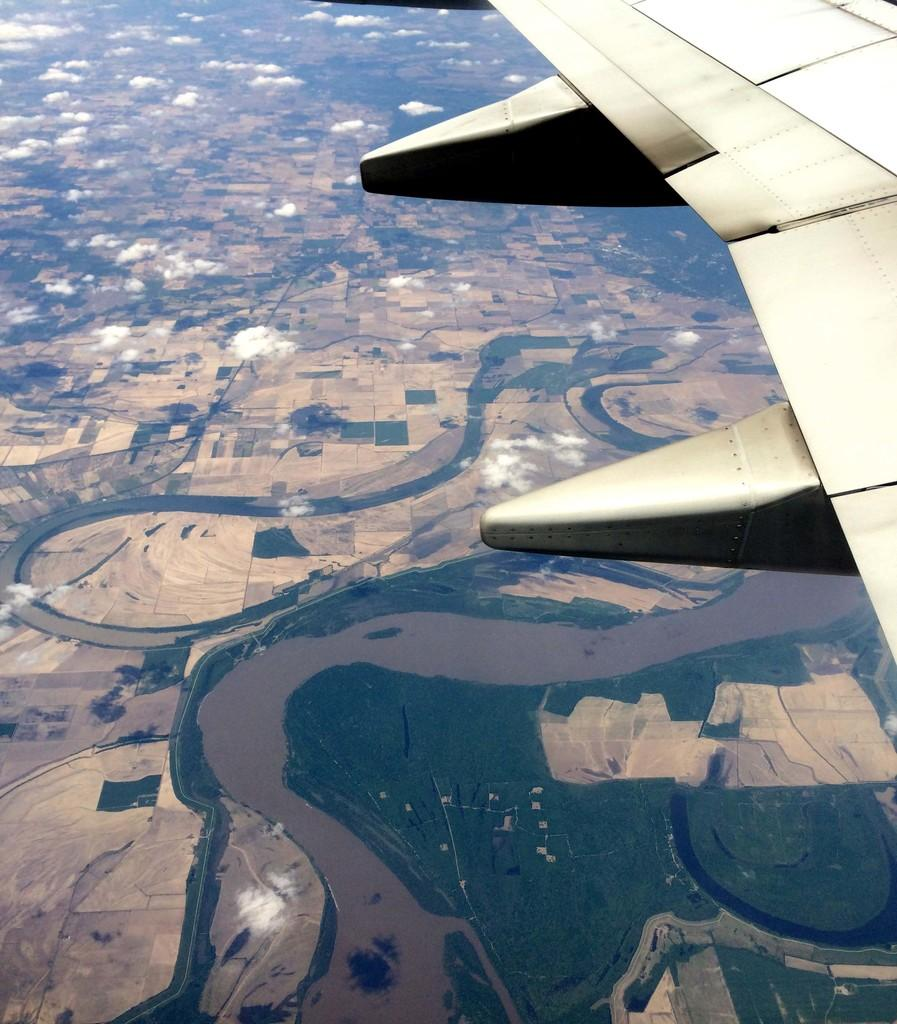What type of surface is visible in the image? There is ground visible in the image. What is located on the right side of the image? There is an aeroplane wing on the right side of the image. How is the aeroplane wing depicted in the image? The aeroplane wing appears to be truncated. What type of invention is being sold for a dime in the image? There is no invention or reference to a dime present in the image. What emotion is being expressed by the aeroplane wing in the image? The aeroplane wing is an inanimate object and cannot express emotions like hate. 